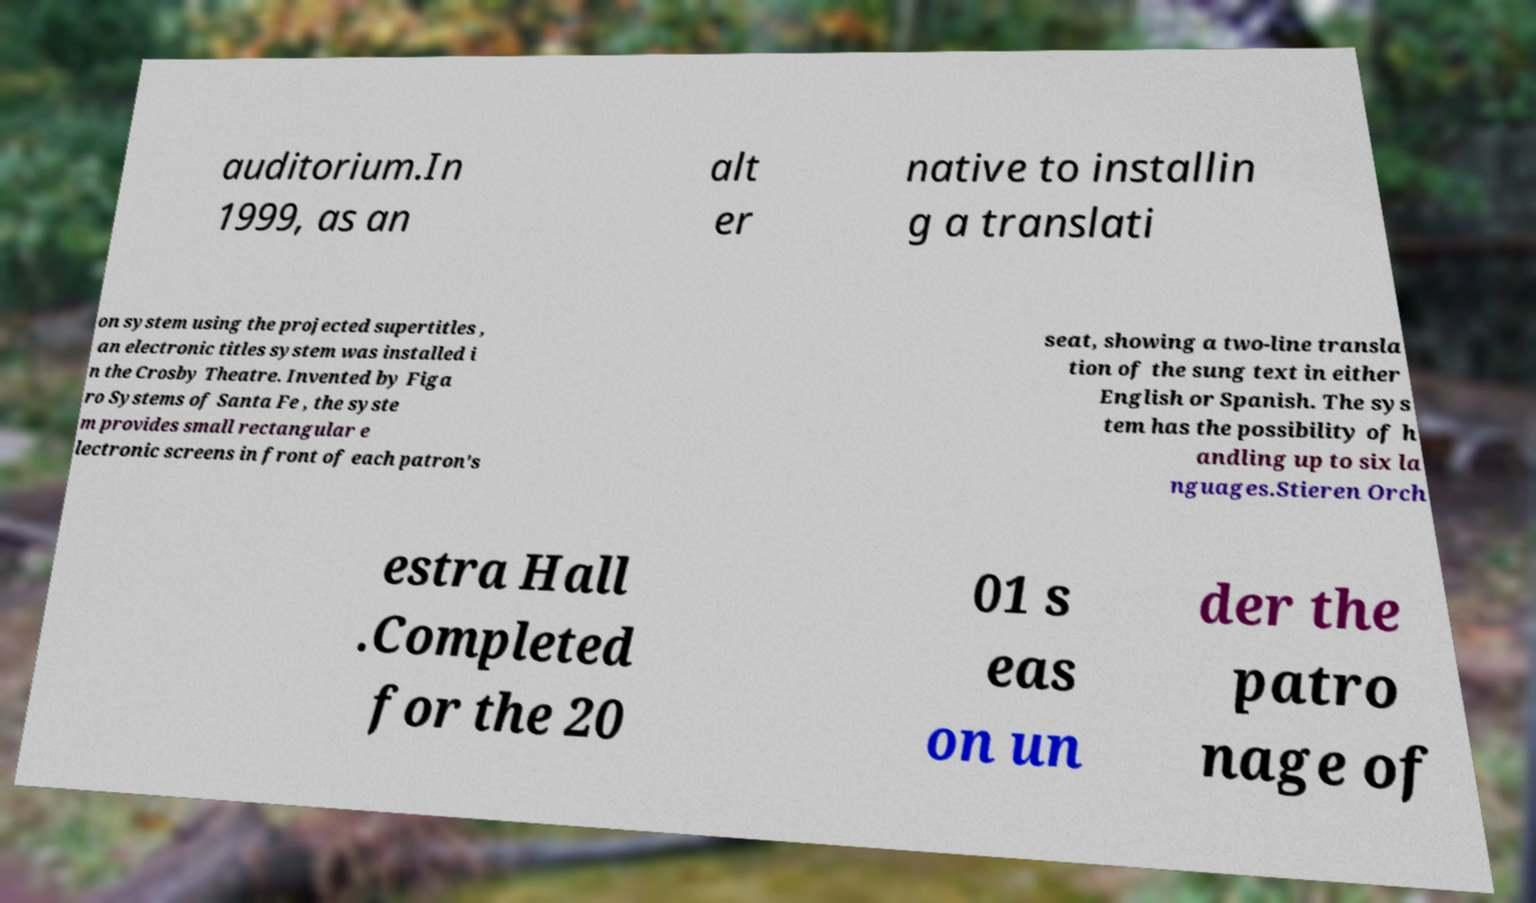Could you assist in decoding the text presented in this image and type it out clearly? auditorium.In 1999, as an alt er native to installin g a translati on system using the projected supertitles , an electronic titles system was installed i n the Crosby Theatre. Invented by Figa ro Systems of Santa Fe , the syste m provides small rectangular e lectronic screens in front of each patron's seat, showing a two-line transla tion of the sung text in either English or Spanish. The sys tem has the possibility of h andling up to six la nguages.Stieren Orch estra Hall .Completed for the 20 01 s eas on un der the patro nage of 